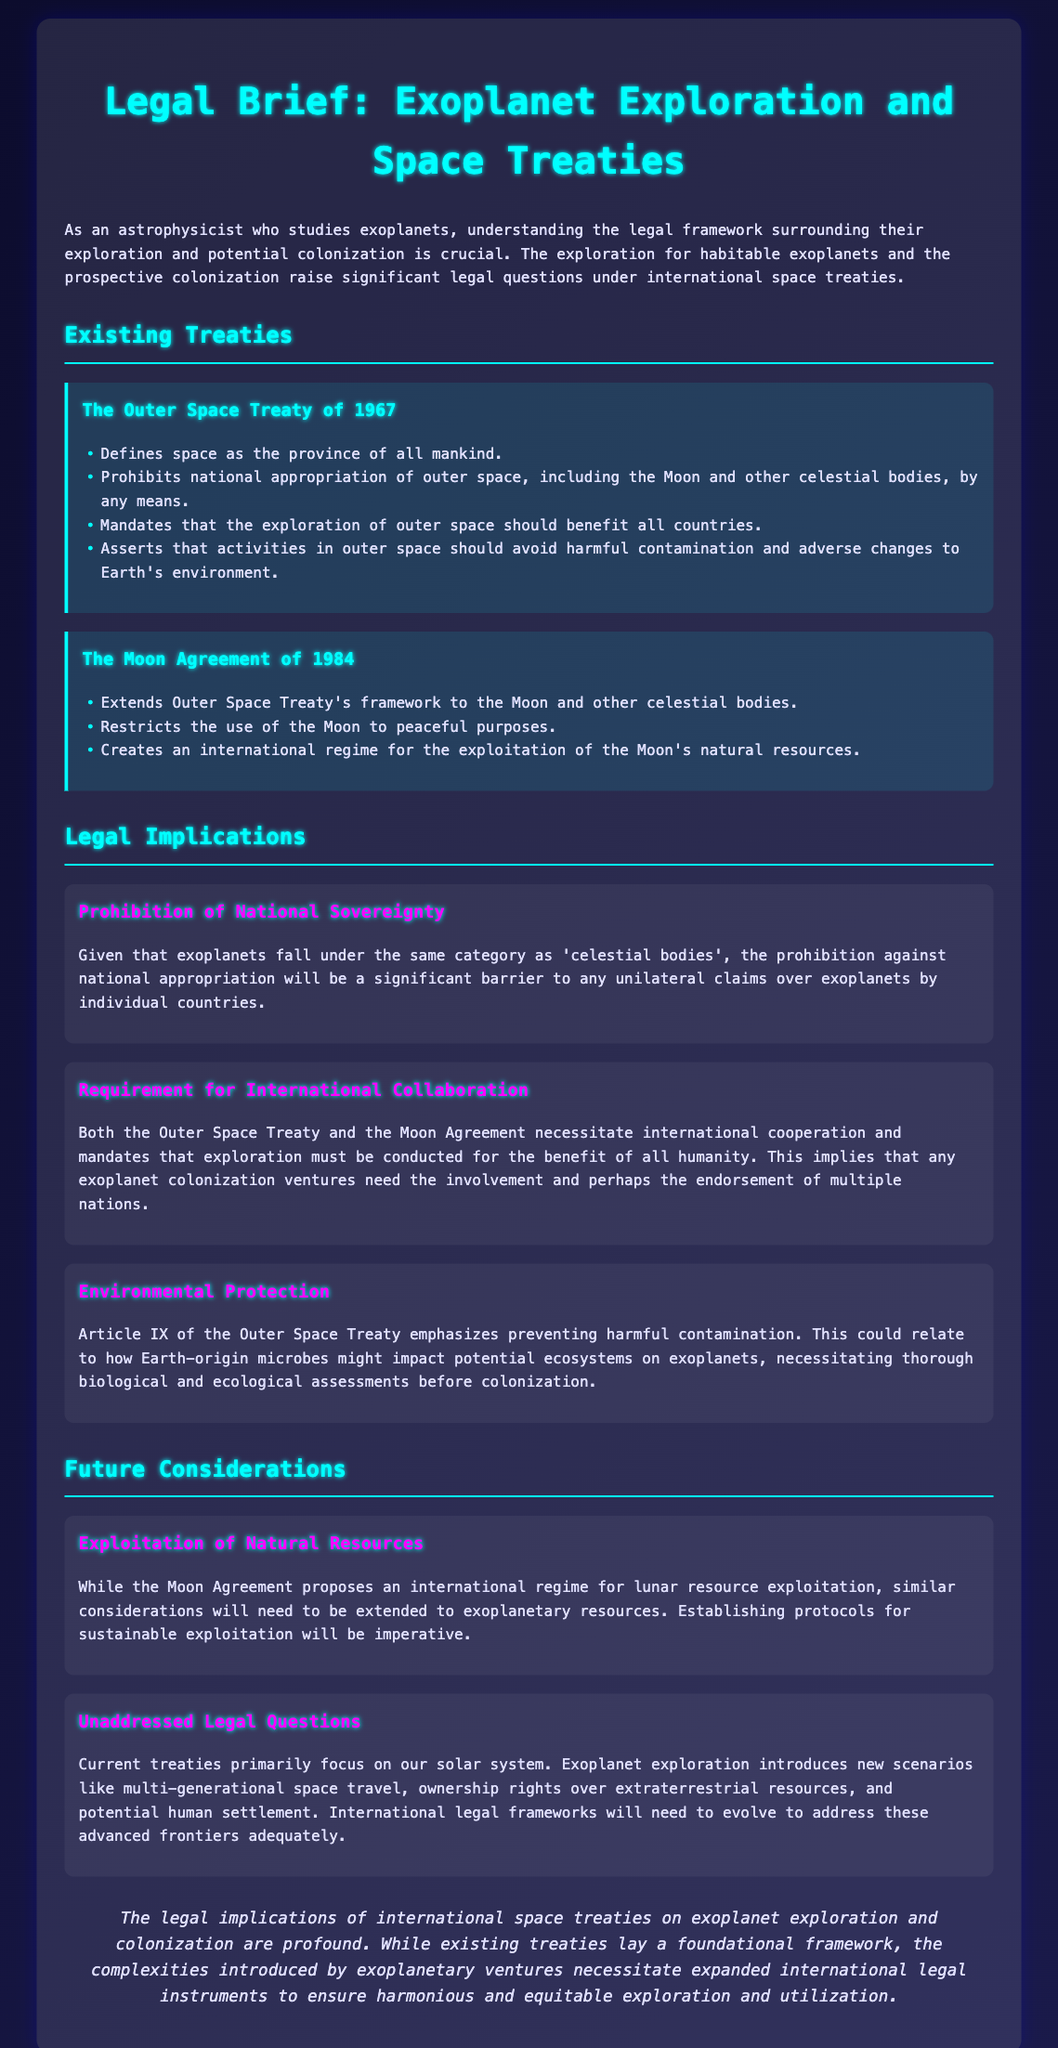What treaty defines space as the province of all mankind? The document states that the Outer Space Treaty of 1967 defines space as the province of all mankind.
Answer: Outer Space Treaty of 1967 What is prohibited by the Outer Space Treaty? According to the document, the Outer Space Treaty prohibits national appropriation of outer space by any means.
Answer: National appropriation What is required under the Outer Space Treaty for exploration? The document mentions that the Outer Space Treaty mandates that exploration should benefit all countries.
Answer: Benefit all countries Which agreement restricts the use of the Moon to peaceful purposes? The document states that the Moon Agreement of 1984 restricts the use of the Moon to peaceful purposes.
Answer: Moon Agreement What must be involved in exoplanet colonization ventures? The document indicates that exoplanet colonization ventures need the involvement and endorsement of multiple nations.
Answer: Multiple nations What environmental aspect is emphasized in Article IX of the Outer Space Treaty? The document notes that Article IX emphasizes preventing harmful contamination of ecosystems.
Answer: Preventing harmful contamination What is proposed for lunar resource exploitation in the Moon Agreement? According to the document, the Moon Agreement proposes an international regime for lunar resource exploitation.
Answer: International regime What is a legal question that remains unaddressed in current treaties? The document identifies ownership rights over extraterrestrial resources as an unaddressed legal question.
Answer: Ownership rights What is the conclusion drawn about existing treaties regarding exoplanets? The conclusion in the document states that existing treaties lay a foundational framework for exoplanet exploration.
Answer: Foundational framework 